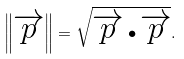<formula> <loc_0><loc_0><loc_500><loc_500>\left \| \overrightarrow { p } \right \| = \sqrt { \overrightarrow { p } \bullet \overrightarrow { p } } .</formula> 